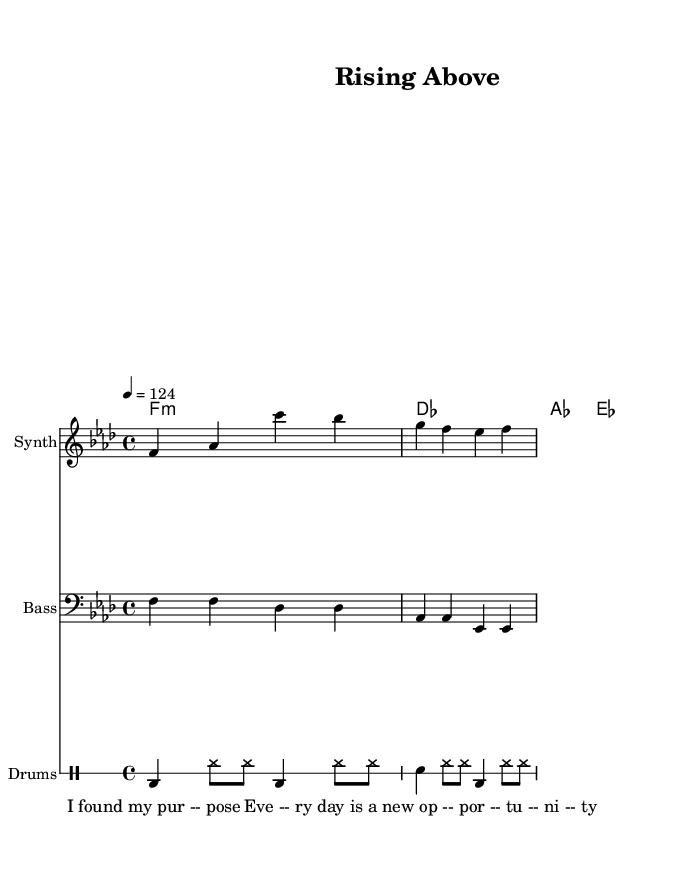What is the key signature of this music? The key signature is indicated by the presence of flat symbols at the beginning of the staff. In this case, it shows four flats, which corresponds to the key of F minor.
Answer: F minor What is the time signature of this music? The time signature is found at the start of the sheet music, represented above the staff. Here, it shows 4/4, meaning there are four beats in a measure and a quarter note receives one beat.
Answer: 4/4 What is the tempo marking for this piece? The tempo marking is usually notated above the staff in beats per minute. In this score, it is indicated as "4 = 124," which means the quarter note is played at a speed of 124 beats per minute.
Answer: 124 How many measures are present in the synth lead section? By counting the individual grouped four beats in the synth lead part, we determine that there are two measures of music written.
Answer: 2 What type of instrument is used for the bass line? The instrument is identified clearly in the sheet music by the label next to the staff. Here, it states "Bass," indicating that a bass instrument is playing this line.
Answer: Bass What phrases are used in the spoken word section? The spoken word section contains lyrics that are presented below the staff. The phrases are "I found my purpose" and "Every day is a new opportunity." These indicate the motivational themes of the piece.
Answer: "I found my purpose"; "Every day is a new opportunity." What is the primary genre of the music represented in this sheet? The genre can typically be identified by the style of the chord progressions and the rhythmic patterns. Given the use of deep house elements and the structured beat pattern, it aligns closely with the House genre.
Answer: House 